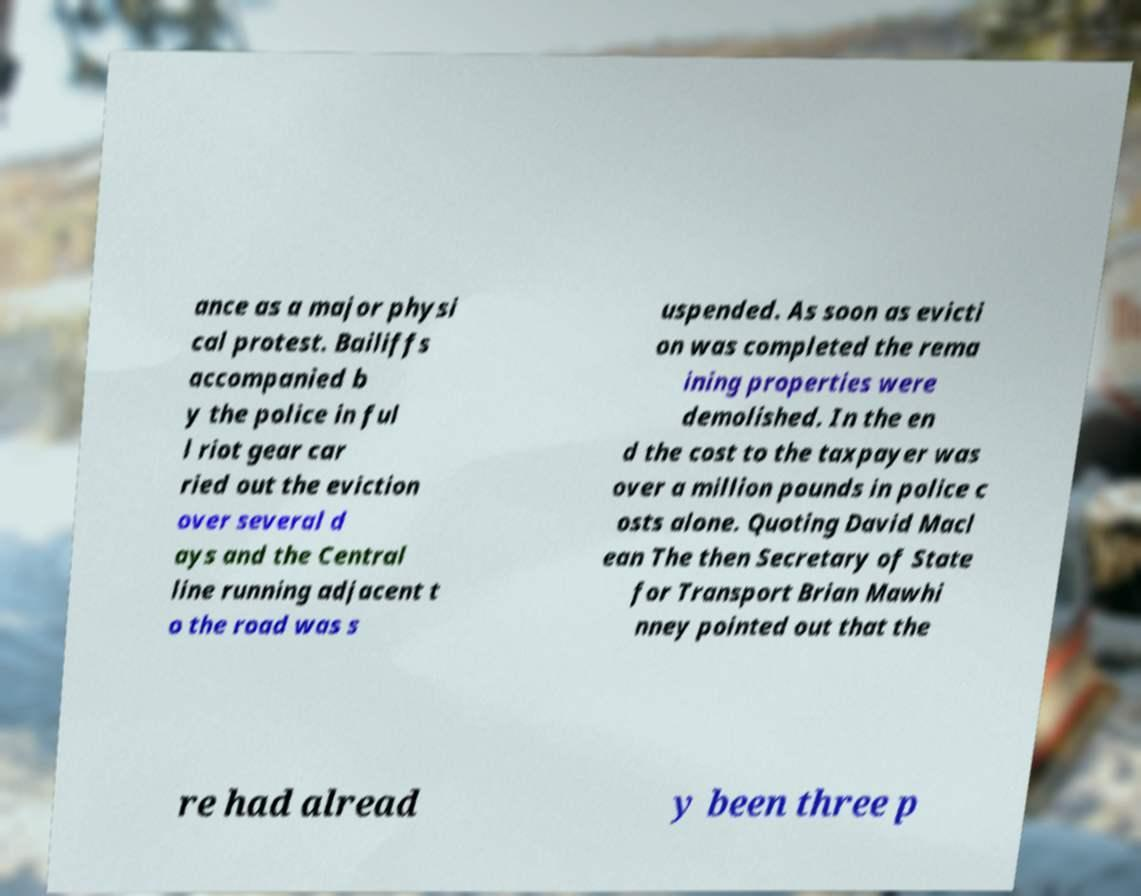Could you extract and type out the text from this image? ance as a major physi cal protest. Bailiffs accompanied b y the police in ful l riot gear car ried out the eviction over several d ays and the Central line running adjacent t o the road was s uspended. As soon as evicti on was completed the rema ining properties were demolished. In the en d the cost to the taxpayer was over a million pounds in police c osts alone. Quoting David Macl ean The then Secretary of State for Transport Brian Mawhi nney pointed out that the re had alread y been three p 